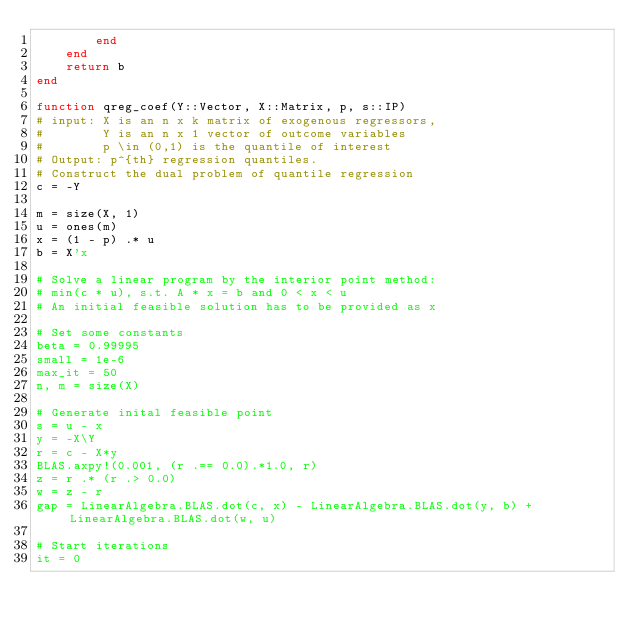Convert code to text. <code><loc_0><loc_0><loc_500><loc_500><_Julia_>        end
    end
    return b
end

function qreg_coef(Y::Vector, X::Matrix, p, s::IP)
# input: X is an n x k matrix of exogenous regressors,
#        Y is an n x 1 vector of outcome variables
#        p \in (0,1) is the quantile of interest
# Output: p^{th} regression quantiles.
# Construct the dual problem of quantile regression
c = -Y

m = size(X, 1)
u = ones(m)
x = (1 - p) .* u
b = X'x

# Solve a linear program by the interior point method:
# min(c * u), s.t. A * x = b and 0 < x < u
# An initial feasible solution has to be provided as x

# Set some constants
beta = 0.99995
small = 1e-6
max_it = 50
n, m = size(X)

# Generate inital feasible point
s = u - x
y = -X\Y
r = c - X*y
BLAS.axpy!(0.001, (r .== 0.0).*1.0, r)
z = r .* (r .> 0.0)
w = z - r
gap = LinearAlgebra.BLAS.dot(c, x) - LinearAlgebra.BLAS.dot(y, b) + LinearAlgebra.BLAS.dot(w, u)

# Start iterations
it = 0</code> 